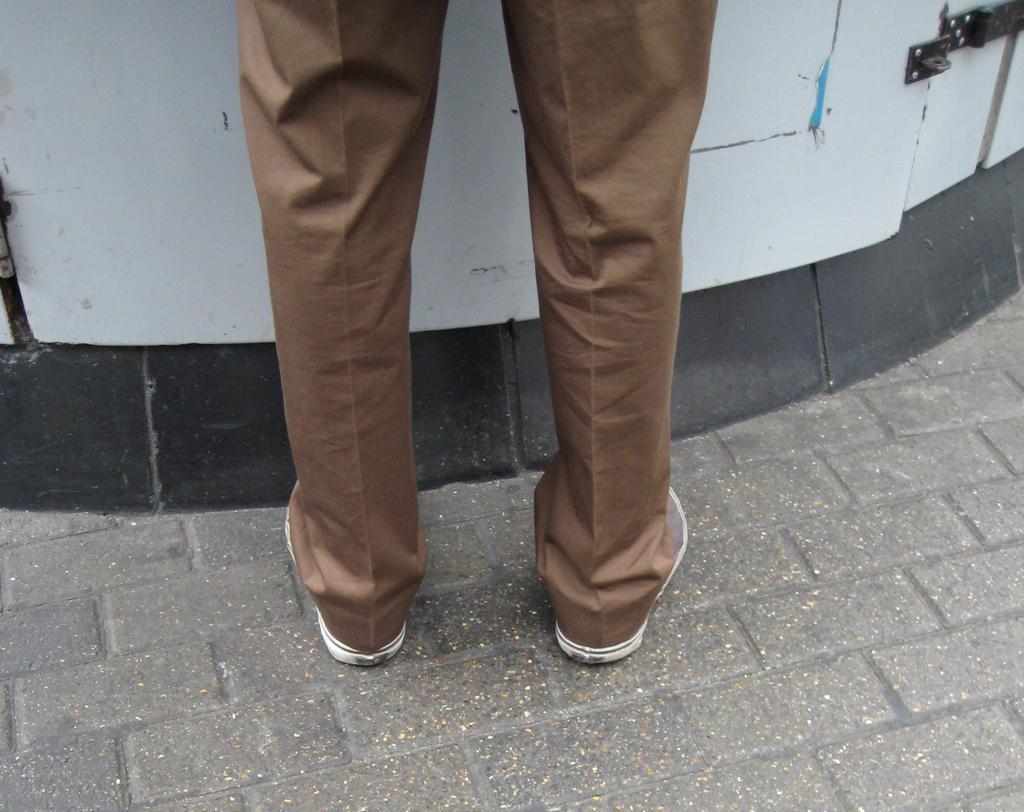How would you summarize this image in a sentence or two? Here in this picture we can see a person's legs, as he is standing on the ground over there and in front of him we can see a door present over there. 